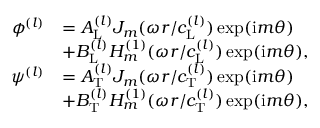Convert formula to latex. <formula><loc_0><loc_0><loc_500><loc_500>\begin{array} { r l } { \phi ^ { ( l ) } } & { = A _ { L } ^ { ( l ) } J _ { m } ( \omega r / c _ { L } ^ { ( l ) } ) \exp ( i m \theta ) } \\ & { + B _ { L } ^ { ( l ) } H _ { m } ^ { ( 1 ) } ( \omega r / c _ { L } ^ { ( l ) } ) \exp ( i m \theta ) , } \\ { \psi ^ { ( l ) } } & { = A _ { T } ^ { ( l ) } J _ { m } ( \omega r / c _ { T } ^ { ( l ) } ) \exp ( i m \theta ) } \\ & { + B _ { T } ^ { ( l ) } H _ { m } ^ { ( 1 ) } ( \omega r / c _ { T } ^ { ( l ) } ) \exp ( i m \theta ) , } \end{array}</formula> 